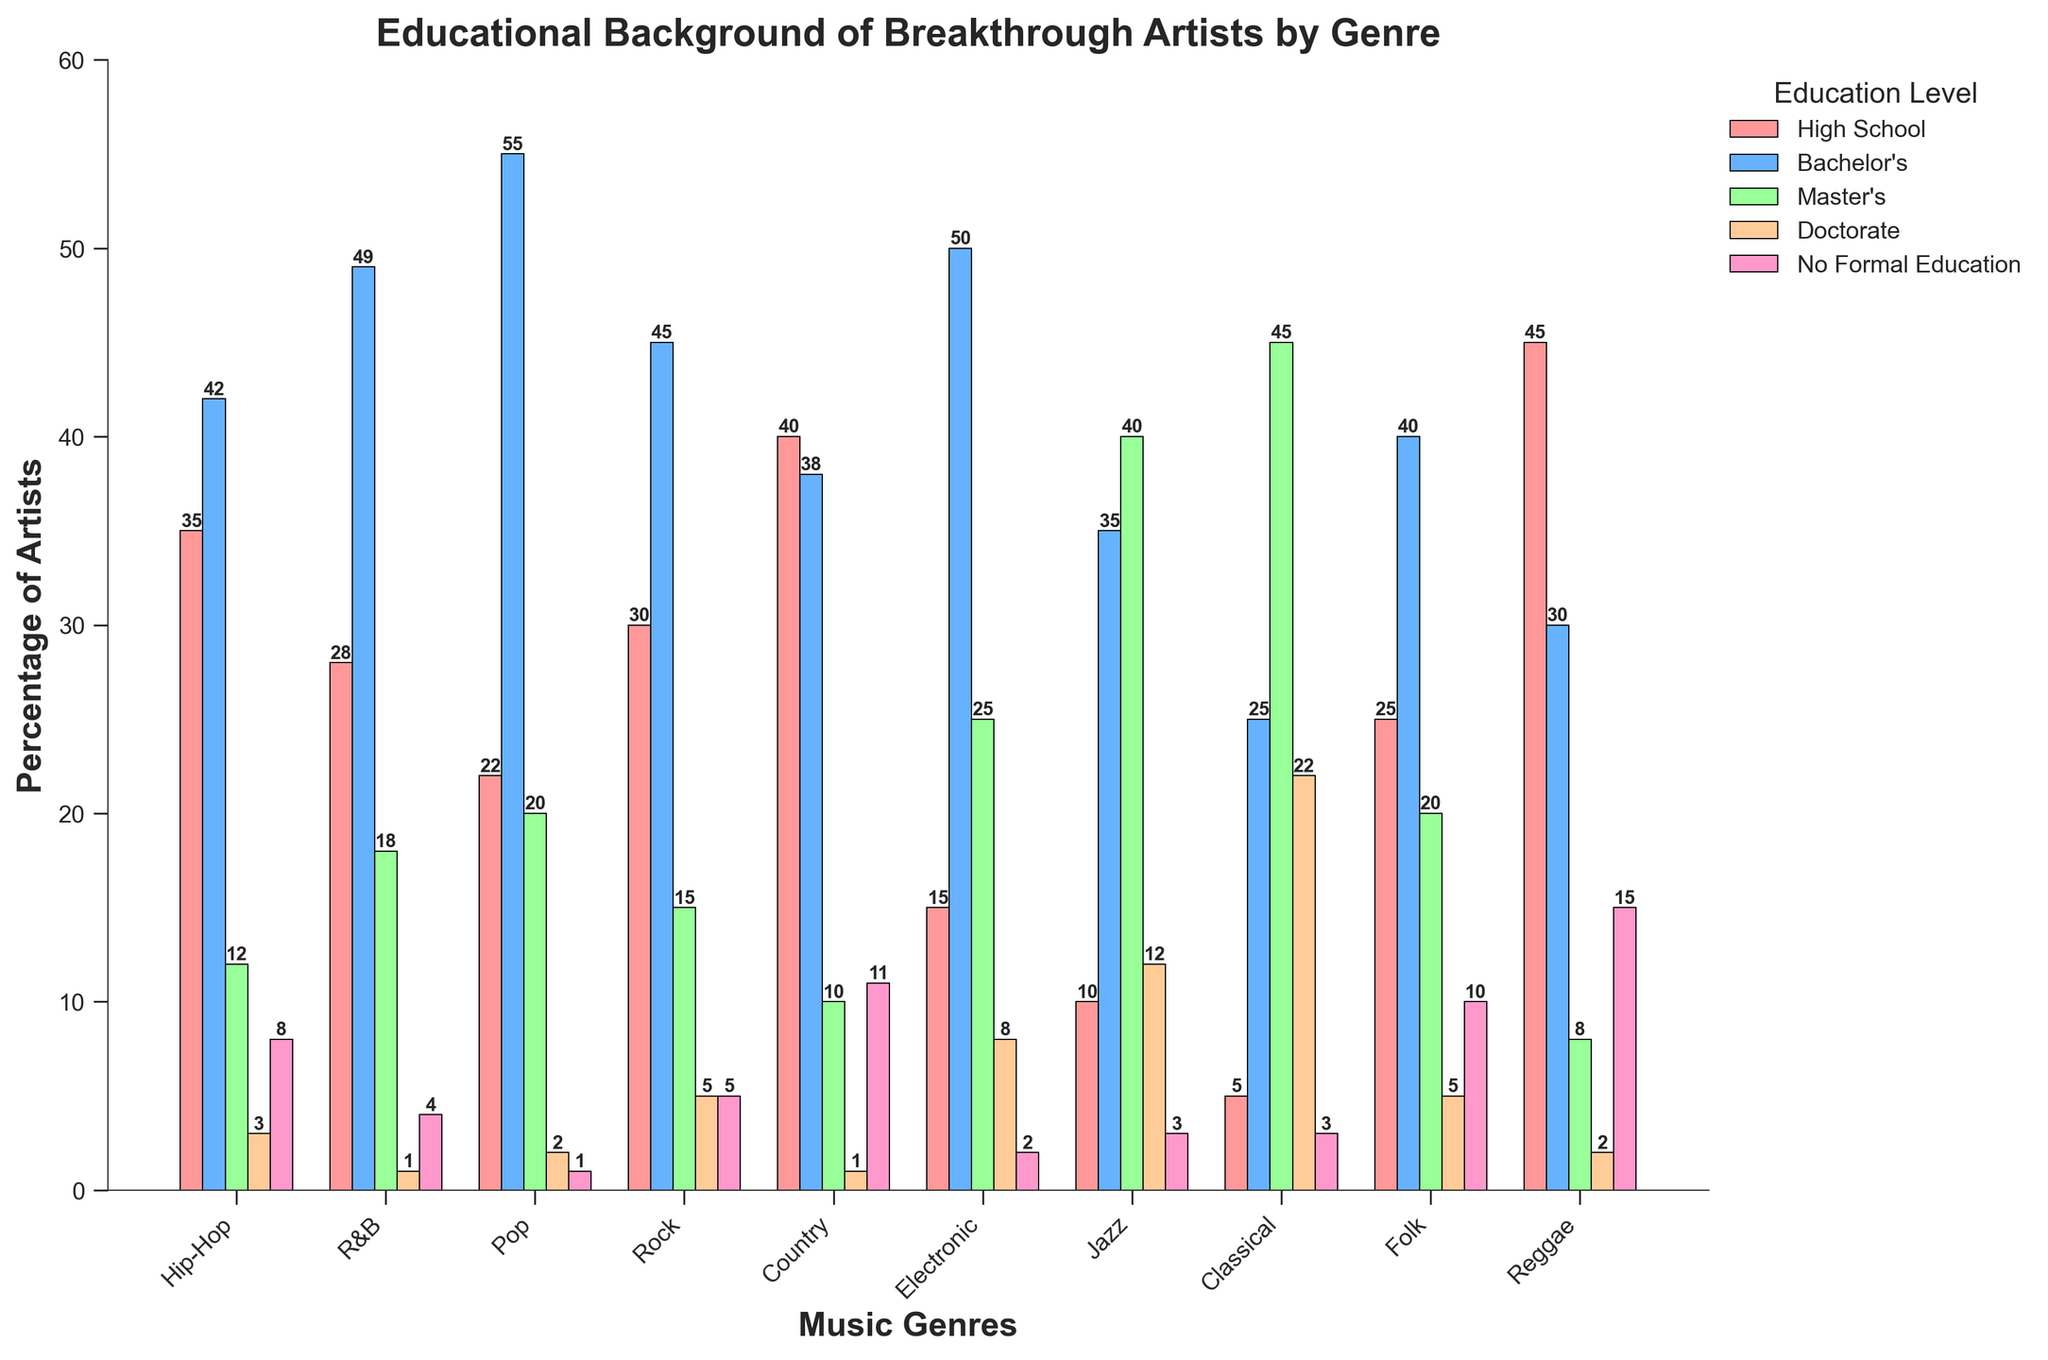Which genre has the highest percentage of artists with no formal education? Look at the "No Formal Education" bars in different genres and find the highest one. Reggae has the highest bar in this category.
Answer: Reggae How many genres have a higher percentage of artists with bachelor's degrees than those with high school education? Compare the heights of the "Bachelor's" bars with the "High School" bars for each genre. Hip-Hop, R&B, Pop, Rock, Electronic, Jazz, and Classical have taller "Bachelor's" bars.
Answer: 7 Which genre shows the highest percentage of artists with a Master's degree? Look at the "Master's" bars in all genres and identify the tallest one. Jazz has the highest bar for the "Master's" category.
Answer: Jazz In which genre do more artists have doctorates compared to no formal education? Compare the bars for "Doctorate" and "No Formal Education" within each genre. Classical and Electronic have taller "Doctorate" bars.
Answer: Classical, Electronic What is the total percentage of Hip-Hop artists who have completed at least a bachelor's degree? Sum the percentages under "Bachelor's", "Master's", and "Doctorate" for Hip-Hop. These are 42, 12, and 3 respectively, summing up to 57.
Answer: 57 Is the percentage of artists with a doctorate degree in Electronic higher than that in Rock and Jazz combined? Sum the "Doctorate" percentages for Rock and Jazz (5 + 12 = 17). Compare it with the "Doctorate" percentage for Electronic (8). 8 is not greater than 17.
Answer: No Which genre has the smallest proportion of artists with just a high school education? Identify the shortest "High School" bar. Classical has the shortest bar in this category.
Answer: Classical How does the percentage of Pop artists with Bachelor's degrees compare to the percentage of Country artists with High School education? Compare the bars for "Bachelor's" in Pop (55) with the "High School" in Country (40). 55 is greater than 40.
Answer: Pop is higher What is the average percentage of artists with a Doctorate degree across all genres? Sum the "Doctorate" percentages and divide by the number of genres (3 + 1 + 2 + 5 + 1 + 8 + 12 + 22 + 5 + 2 = 61). Divide 61 by 10 (number of genres).
Answer: 6.1 In which genre do more artists have Master's degrees than High School and Bachelor's degrees combined? Sum the "High School" and "Bachelor's" percentages for each genre and compare with the "Master's" percentage. No genre fits this condition.
Answer: None 